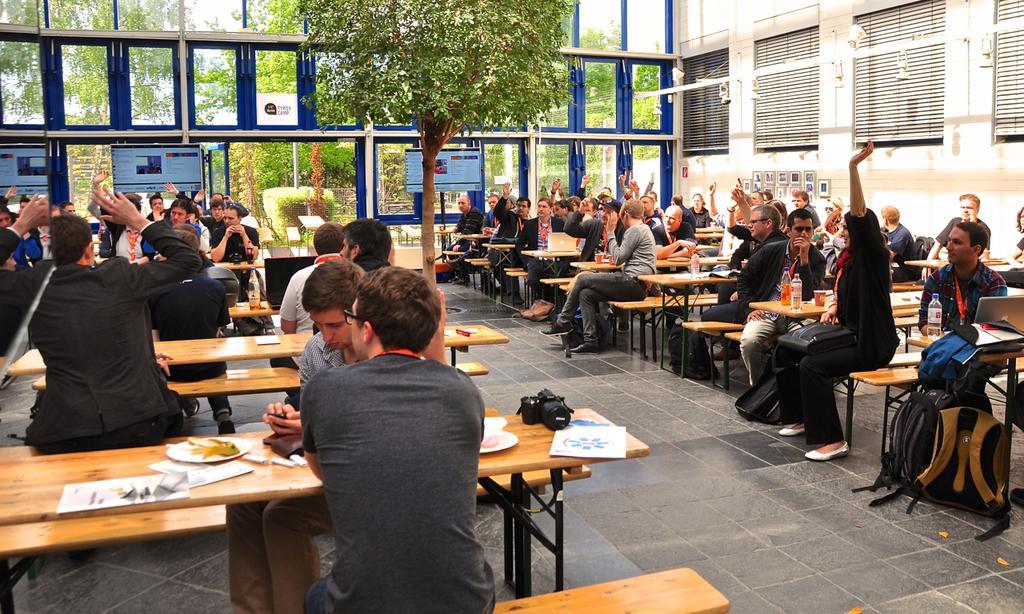Could you give a brief overview of what you see in this image? This is the image of the room where at the right side group of people sitting in the chair or a bench and on the left side there are group of people sitting and in the table there are some papers, plate ,food ,camera at the back ground there is a tree , screens , building and sky , photo frame attached to the wall. 